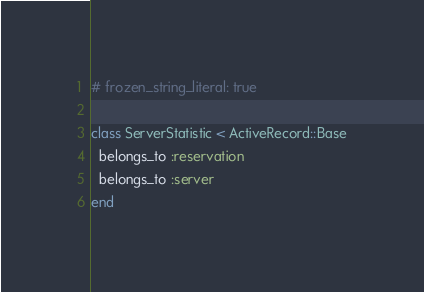<code> <loc_0><loc_0><loc_500><loc_500><_Ruby_># frozen_string_literal: true

class ServerStatistic < ActiveRecord::Base
  belongs_to :reservation
  belongs_to :server
end
</code> 